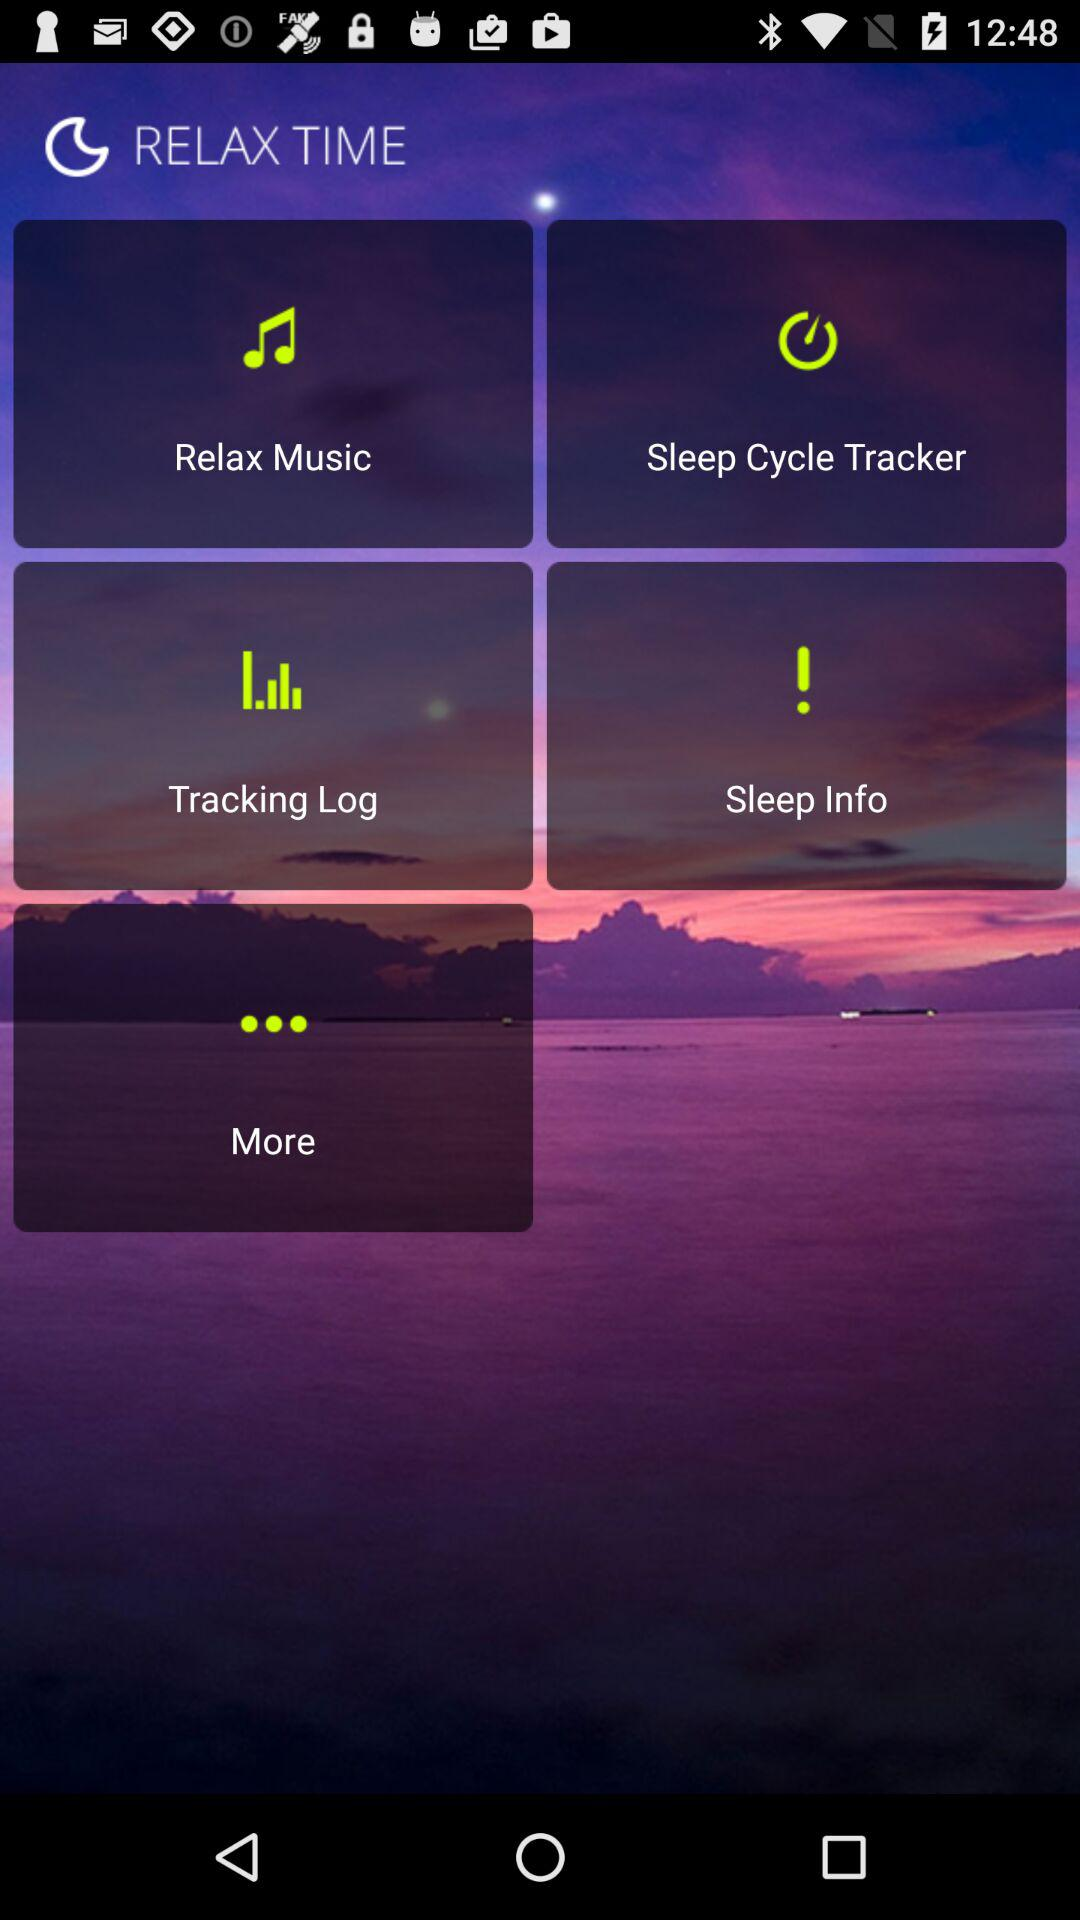What is the name of the application? The name of the application is "RELAX TIME". 